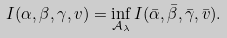Convert formula to latex. <formula><loc_0><loc_0><loc_500><loc_500>I ( \alpha , \beta , \gamma , v ) = \inf _ { \mathcal { A } _ { \lambda } } I ( \bar { \alpha } , \bar { \beta } , \bar { \gamma } , \bar { v } ) .</formula> 